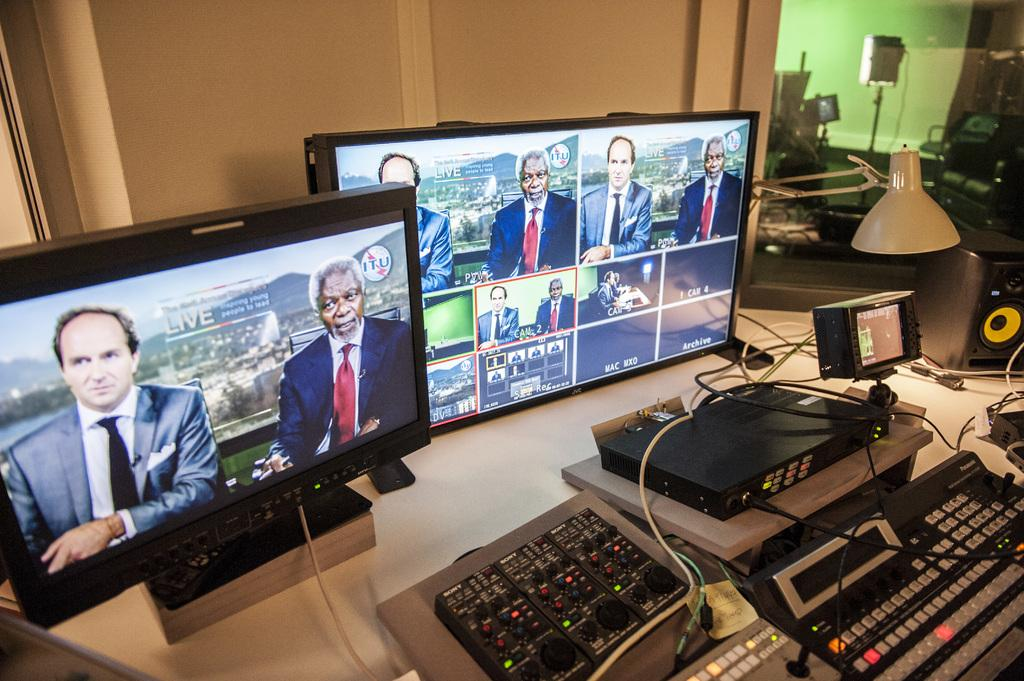Provide a one-sentence caption for the provided image. A live broadcast on two JVC computer monitors. 